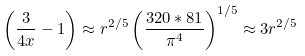<formula> <loc_0><loc_0><loc_500><loc_500>\left ( \frac { 3 } { 4 x } - 1 \right ) \approx r ^ { 2 / 5 } \left ( \frac { 3 2 0 * 8 1 } { \pi ^ { 4 } } \right ) ^ { 1 / 5 } \approx 3 r ^ { 2 / 5 }</formula> 